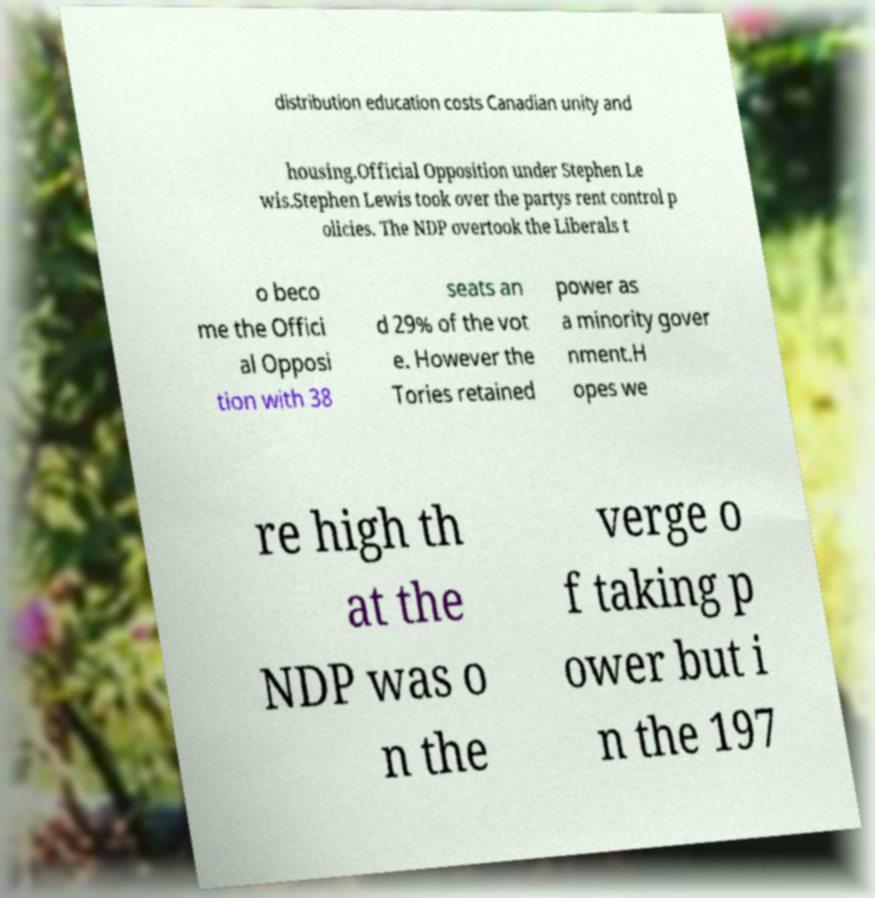For documentation purposes, I need the text within this image transcribed. Could you provide that? distribution education costs Canadian unity and housing.Official Opposition under Stephen Le wis.Stephen Lewis took over the partys rent control p olicies. The NDP overtook the Liberals t o beco me the Offici al Opposi tion with 38 seats an d 29% of the vot e. However the Tories retained power as a minority gover nment.H opes we re high th at the NDP was o n the verge o f taking p ower but i n the 197 